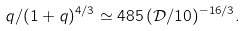<formula> <loc_0><loc_0><loc_500><loc_500>q / ( 1 + q ) ^ { 4 / 3 } \simeq 4 8 5 \, ( \mathcal { D } / 1 0 ) ^ { - 1 6 / 3 } .</formula> 